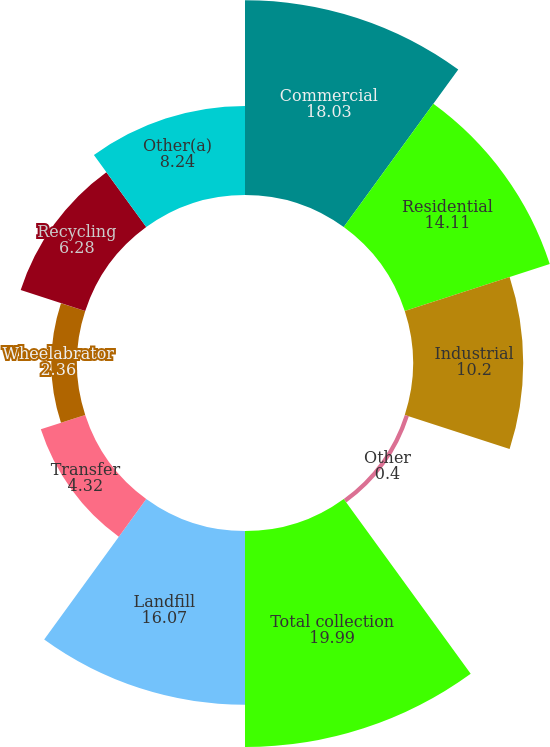Convert chart to OTSL. <chart><loc_0><loc_0><loc_500><loc_500><pie_chart><fcel>Commercial<fcel>Residential<fcel>Industrial<fcel>Other<fcel>Total collection<fcel>Landfill<fcel>Transfer<fcel>Wheelabrator<fcel>Recycling<fcel>Other(a)<nl><fcel>18.03%<fcel>14.11%<fcel>10.2%<fcel>0.4%<fcel>19.99%<fcel>16.07%<fcel>4.32%<fcel>2.36%<fcel>6.28%<fcel>8.24%<nl></chart> 